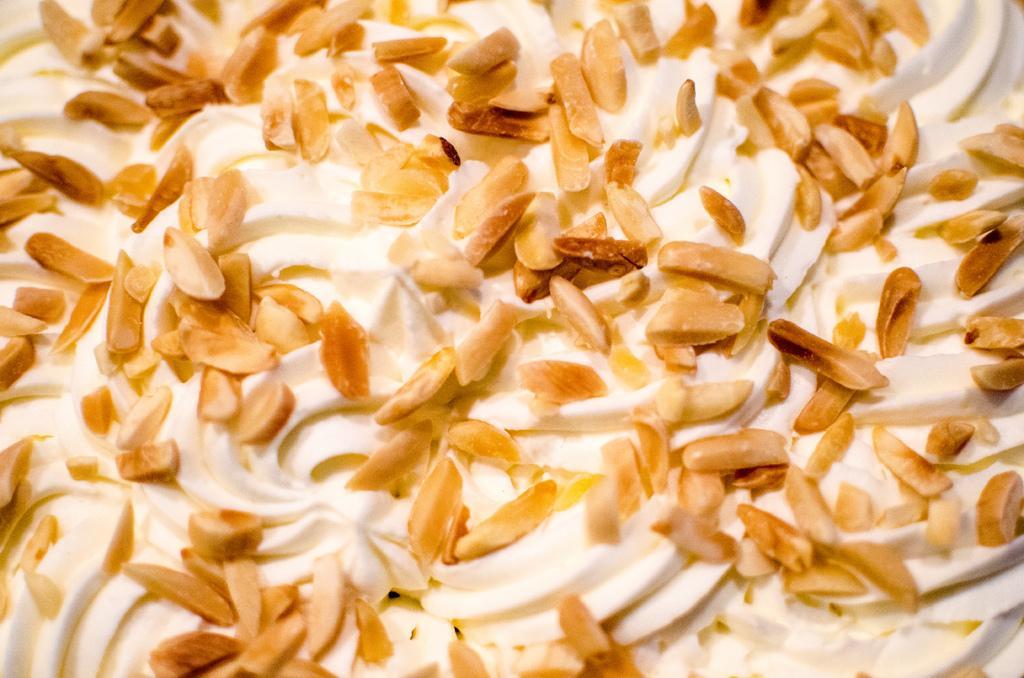Could you give a brief overview of what you see in this image? In the picture we can see dry fruits in the cream. 